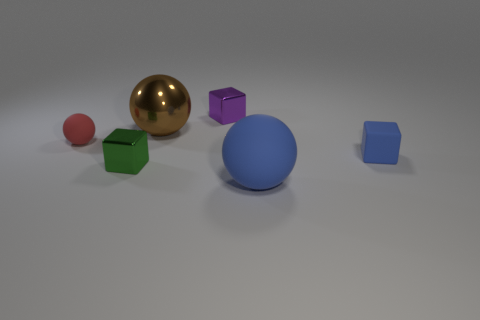Are there any objects that have the same size as the shiny sphere?
Provide a short and direct response. Yes. Do the small metallic thing that is in front of the large brown sphere and the purple metal object have the same shape?
Provide a succinct answer. Yes. Is the shape of the tiny red thing the same as the small blue thing?
Offer a terse response. No. Is there another rubber thing of the same shape as the tiny red thing?
Offer a terse response. Yes. What is the shape of the large brown shiny object that is in front of the purple metallic thing behind the tiny blue matte cube?
Give a very brief answer. Sphere. There is a metal object that is in front of the brown object; what is its color?
Ensure brevity in your answer.  Green. There is a blue block that is the same material as the tiny ball; what is its size?
Provide a short and direct response. Small. What size is the other rubber object that is the same shape as the red thing?
Offer a very short reply. Large. Are there any big matte things?
Offer a very short reply. Yes. What number of things are tiny green shiny objects on the left side of the brown metallic sphere or matte balls?
Offer a very short reply. 3. 